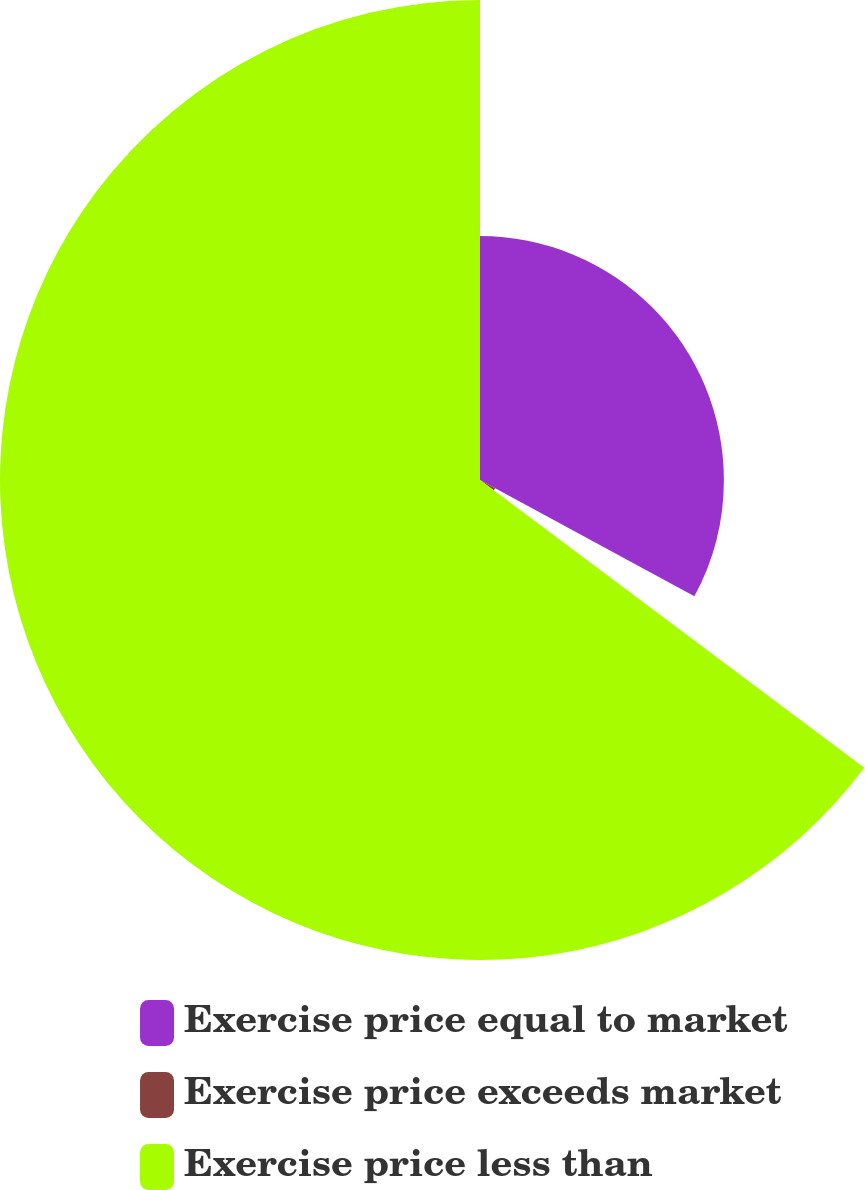<chart> <loc_0><loc_0><loc_500><loc_500><pie_chart><fcel>Exercise price equal to market<fcel>Exercise price exceeds market<fcel>Exercise price less than<nl><fcel>32.91%<fcel>2.32%<fcel>64.77%<nl></chart> 